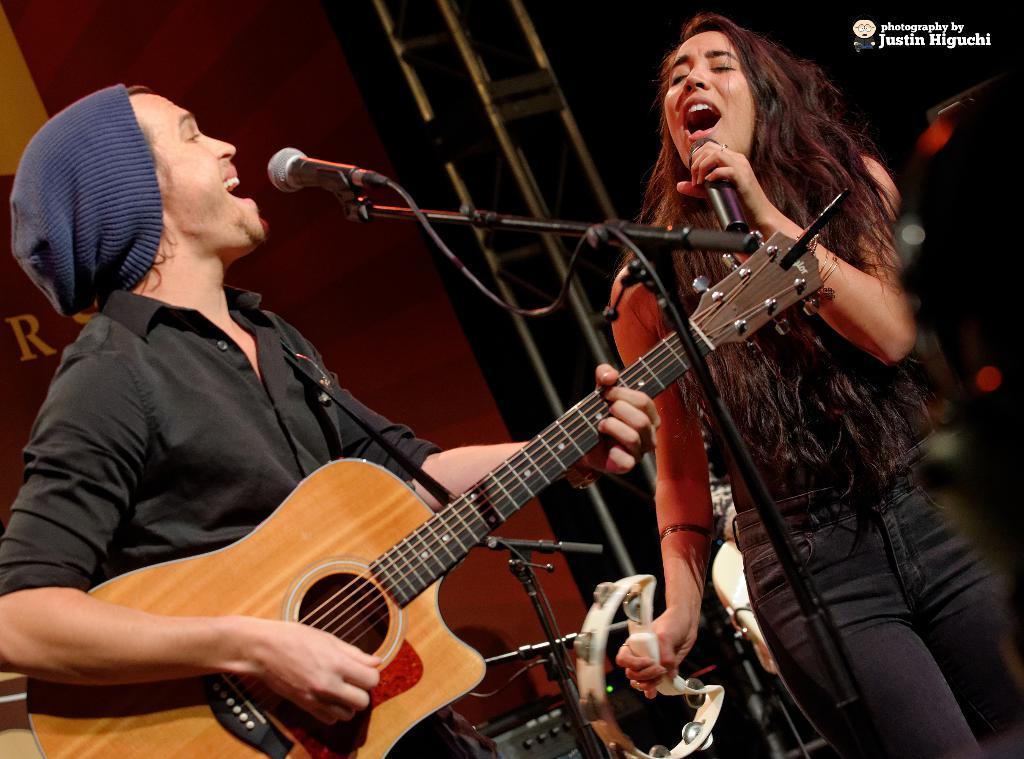Could you give a brief overview of what you see in this image? In this picture there is a man playing a guitar in his hands in front of a mic and another woman singing in front of a mic. In the background there is a wall and a pole here. 